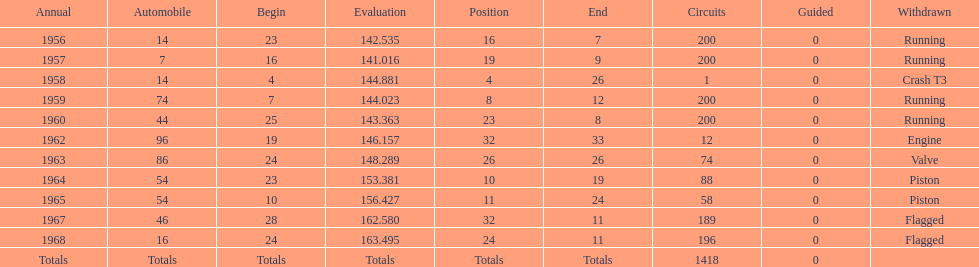How long did bob veith have the number 54 car at the indy 500? 2 years. Would you be able to parse every entry in this table? {'header': ['Annual', 'Automobile', 'Begin', 'Evaluation', 'Position', 'End', 'Circuits', 'Guided', 'Withdrawn'], 'rows': [['1956', '14', '23', '142.535', '16', '7', '200', '0', 'Running'], ['1957', '7', '16', '141.016', '19', '9', '200', '0', 'Running'], ['1958', '14', '4', '144.881', '4', '26', '1', '0', 'Crash T3'], ['1959', '74', '7', '144.023', '8', '12', '200', '0', 'Running'], ['1960', '44', '25', '143.363', '23', '8', '200', '0', 'Running'], ['1962', '96', '19', '146.157', '32', '33', '12', '0', 'Engine'], ['1963', '86', '24', '148.289', '26', '26', '74', '0', 'Valve'], ['1964', '54', '23', '153.381', '10', '19', '88', '0', 'Piston'], ['1965', '54', '10', '156.427', '11', '24', '58', '0', 'Piston'], ['1967', '46', '28', '162.580', '32', '11', '189', '0', 'Flagged'], ['1968', '16', '24', '163.495', '24', '11', '196', '0', 'Flagged'], ['Totals', 'Totals', 'Totals', 'Totals', 'Totals', 'Totals', '1418', '0', '']]} 